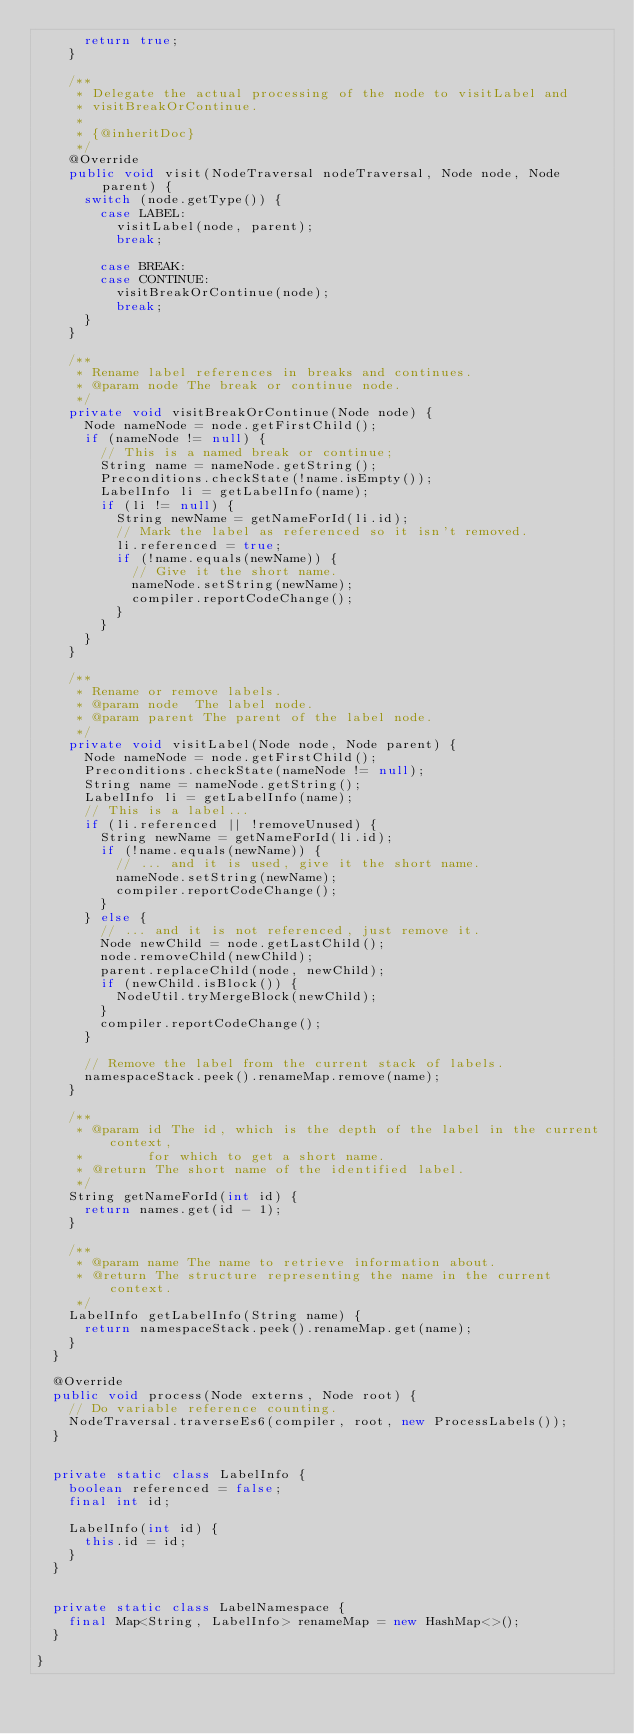Convert code to text. <code><loc_0><loc_0><loc_500><loc_500><_Java_>      return true;
    }

    /**
     * Delegate the actual processing of the node to visitLabel and
     * visitBreakOrContinue.
     *
     * {@inheritDoc}
     */
    @Override
    public void visit(NodeTraversal nodeTraversal, Node node, Node parent) {
      switch (node.getType()) {
        case LABEL:
          visitLabel(node, parent);
          break;

        case BREAK:
        case CONTINUE:
          visitBreakOrContinue(node);
          break;
      }
    }

    /**
     * Rename label references in breaks and continues.
     * @param node The break or continue node.
     */
    private void visitBreakOrContinue(Node node) {
      Node nameNode = node.getFirstChild();
      if (nameNode != null) {
        // This is a named break or continue;
        String name = nameNode.getString();
        Preconditions.checkState(!name.isEmpty());
        LabelInfo li = getLabelInfo(name);
        if (li != null) {
          String newName = getNameForId(li.id);
          // Mark the label as referenced so it isn't removed.
          li.referenced = true;
          if (!name.equals(newName)) {
            // Give it the short name.
            nameNode.setString(newName);
            compiler.reportCodeChange();
          }
        }
      }
    }

    /**
     * Rename or remove labels.
     * @param node  The label node.
     * @param parent The parent of the label node.
     */
    private void visitLabel(Node node, Node parent) {
      Node nameNode = node.getFirstChild();
      Preconditions.checkState(nameNode != null);
      String name = nameNode.getString();
      LabelInfo li = getLabelInfo(name);
      // This is a label...
      if (li.referenced || !removeUnused) {
        String newName = getNameForId(li.id);
        if (!name.equals(newName)) {
          // ... and it is used, give it the short name.
          nameNode.setString(newName);
          compiler.reportCodeChange();
        }
      } else {
        // ... and it is not referenced, just remove it.
        Node newChild = node.getLastChild();
        node.removeChild(newChild);
        parent.replaceChild(node, newChild);
        if (newChild.isBlock()) {
          NodeUtil.tryMergeBlock(newChild);
        }
        compiler.reportCodeChange();
      }

      // Remove the label from the current stack of labels.
      namespaceStack.peek().renameMap.remove(name);
    }

    /**
     * @param id The id, which is the depth of the label in the current context,
     *        for which to get a short name.
     * @return The short name of the identified label.
     */
    String getNameForId(int id) {
      return names.get(id - 1);
    }

    /**
     * @param name The name to retrieve information about.
     * @return The structure representing the name in the current context.
     */
    LabelInfo getLabelInfo(String name) {
      return namespaceStack.peek().renameMap.get(name);
    }
  }

  @Override
  public void process(Node externs, Node root) {
    // Do variable reference counting.
    NodeTraversal.traverseEs6(compiler, root, new ProcessLabels());
  }


  private static class LabelInfo {
    boolean referenced = false;
    final int id;

    LabelInfo(int id) {
      this.id = id;
    }
  }


  private static class LabelNamespace {
    final Map<String, LabelInfo> renameMap = new HashMap<>();
  }

}
</code> 